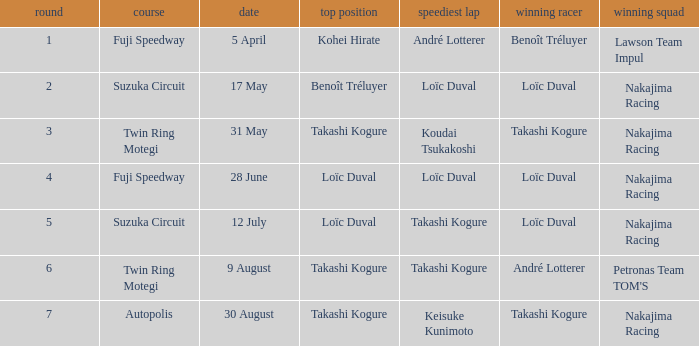Who has the fastest lap where Benoît Tréluyer got the pole position? Loïc Duval. 